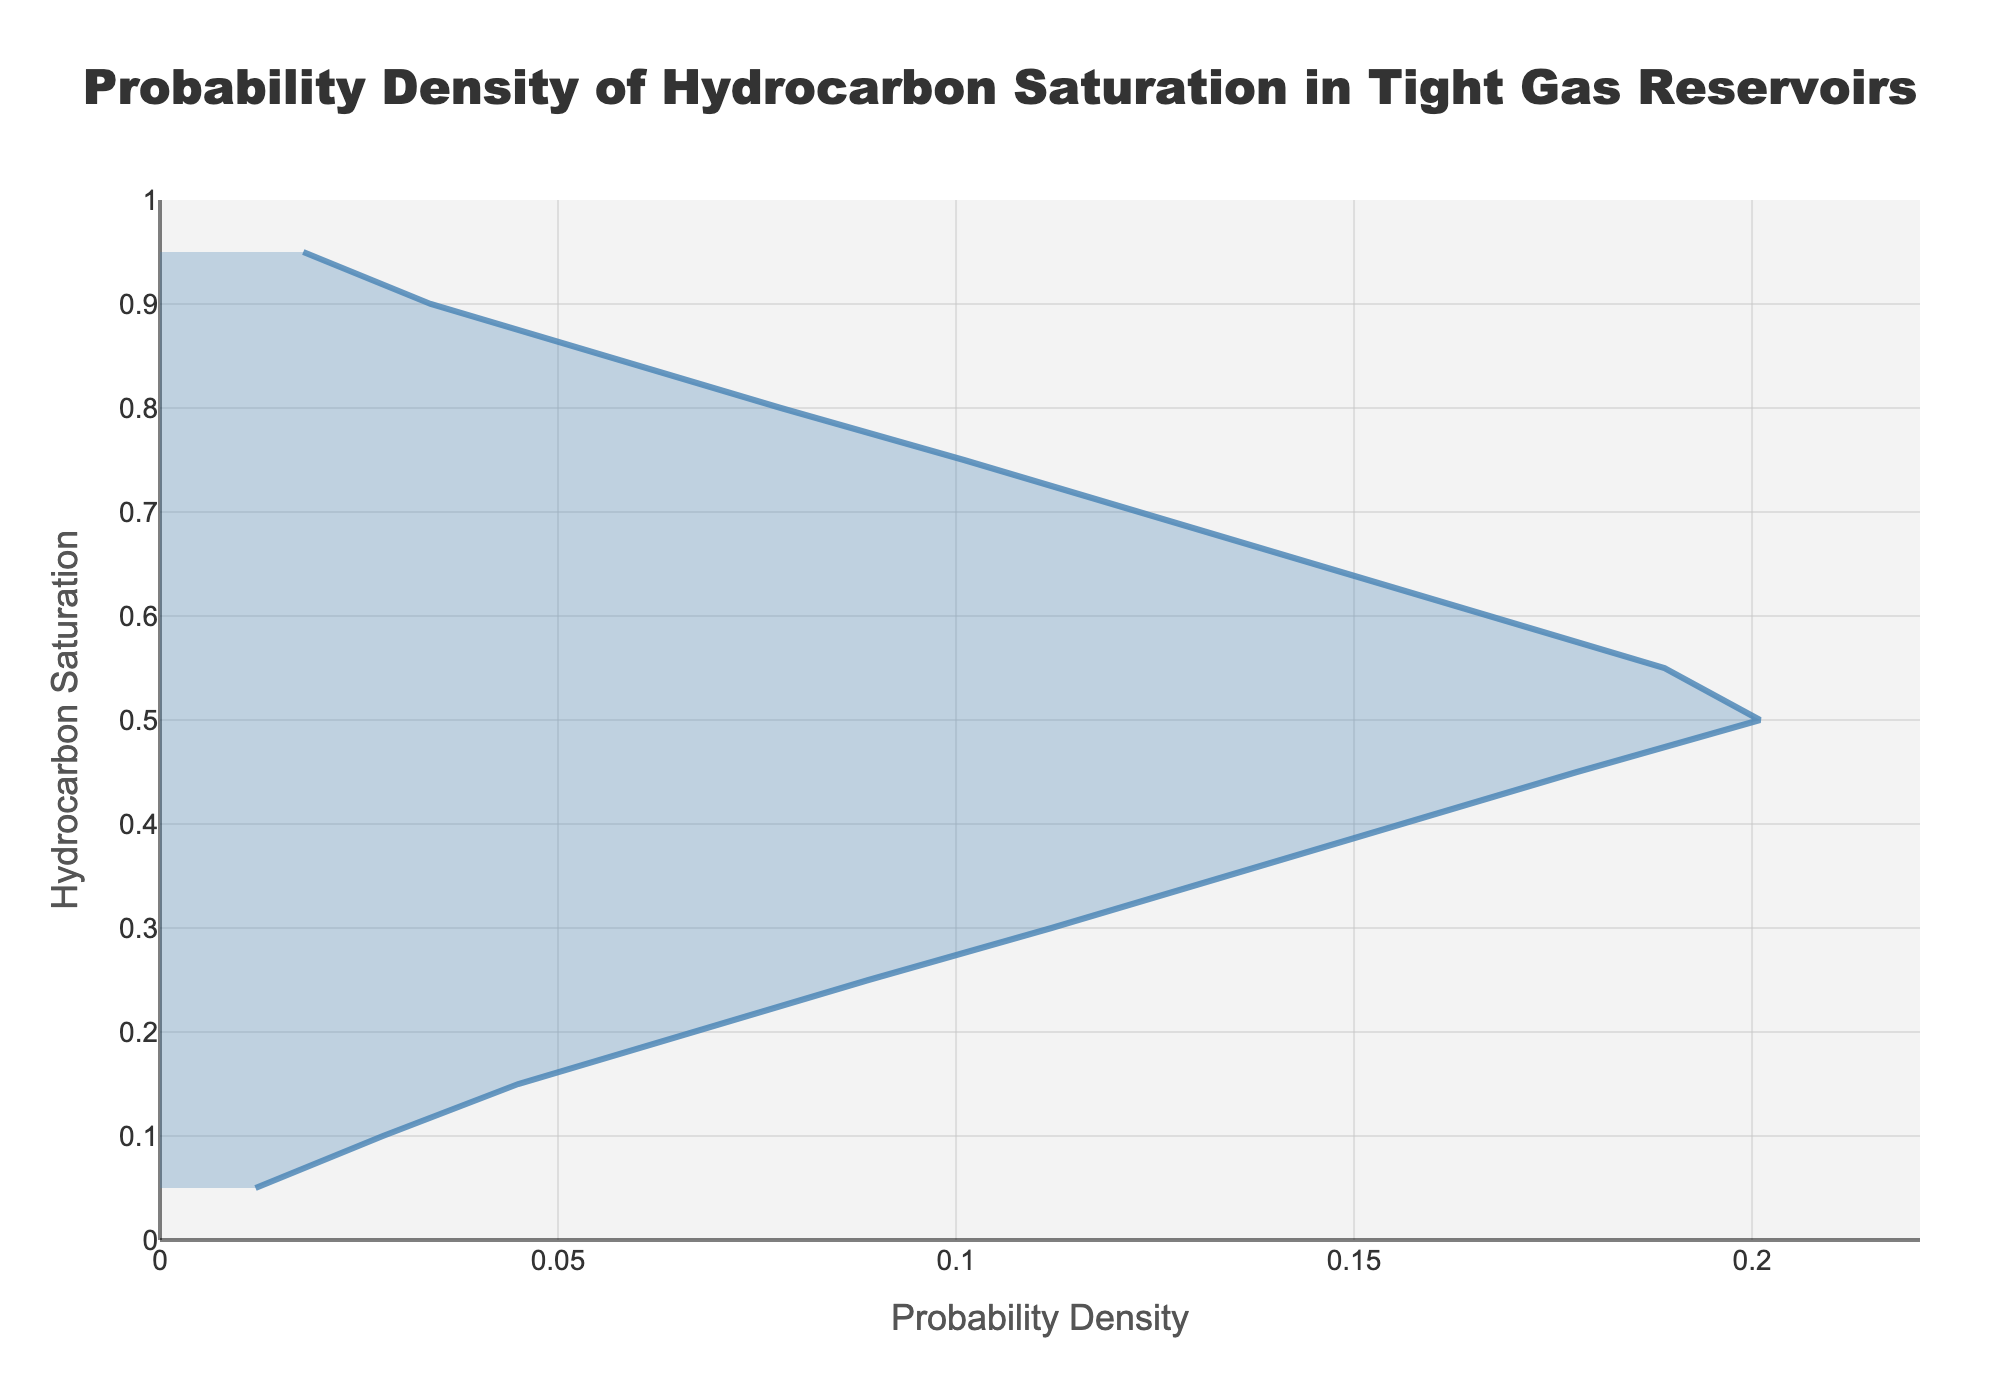What is the title of the plot? The title can be found at the top of the plot. It reads "Probability Density of Hydrocarbon Saturation in Tight Gas Reservoirs".
Answer: Probability Density of Hydrocarbon Saturation in Tight Gas Reservoirs What are the labels of the X and Y axes? The X-axis is labeled "Probability Density", and the Y-axis is labeled "Hydrocarbon Saturation". These labels are textual descriptions that are positioned next to their respective axes on the plot.
Answer: Probability Density and Hydrocarbon Saturation What is the maximum probability density value shown in the plot? The maximum value can be identified by looking at the peak of the density curve along the X-axis. The highest density value is 0.201.
Answer: 0.201 At what hydrocarbon saturation value does the probability density reach its peak? The peak probability density occurs where the Y-axis value (Hydrocarbon Saturation) corresponds to the maximum X-axis value (Density). The peak occurs at a hydrocarbon saturation value of 0.50.
Answer: 0.50 Describe the trend of the probability density as the hydrocarbon saturation increases from 0.05 to 0.50. As hydrocarbon saturation increases from 0.05 to 0.50, the probability density shows a rising trend, indicating a higher probability of these saturation values occurring in the reservoir. This can be observed by the upward slope of the curve from the left (0.05) to the peak (0.50).
Answer: Increasing How does the probability density change as hydrocarbon saturation moves from 0.50 to 0.95? After reaching the peak at 0.50, the probability density decreases as the hydrocarbon saturation increases towards 0.95. This decline is depicted by the downward slope of the curve from 0.50 to 0.95.
Answer: Decreasing What is the range of hydrocarbon saturation values shown in the plot? The range is defined by the minimum and maximum values on the Y-axis. From the plot, the hydrocarbon saturation values range from 0.05 to 0.95.
Answer: 0.05 to 0.95 Compare the probability density at hydrocarbon saturation values of 0.35 and 0.65. Which one is higher? To determine which value is higher, compare the density values at saturations 0.35 and 0.65 on the plot. The density at 0.35 is 0.134, while at 0.65 it is 0.145. Therefore, the density at 0.65 is slightly higher.
Answer: 0.65 What is the probability density at a hydrocarbon saturation of 0.70? Locate 0.70 on the Y-axis (Hydrocarbon Saturation) and refer to the corresponding density value on the X-axis. The density value at 0.70 is 0.123.
Answer: 0.123 Between which two hydrocarbon saturation values does the probability density decline the most? Observe the sections of the curve where the decline is steepest by comparing intervals along the Y-axis. The sharpest decline is between 0.50 and 0.55.
Answer: 0.50 and 0.55 